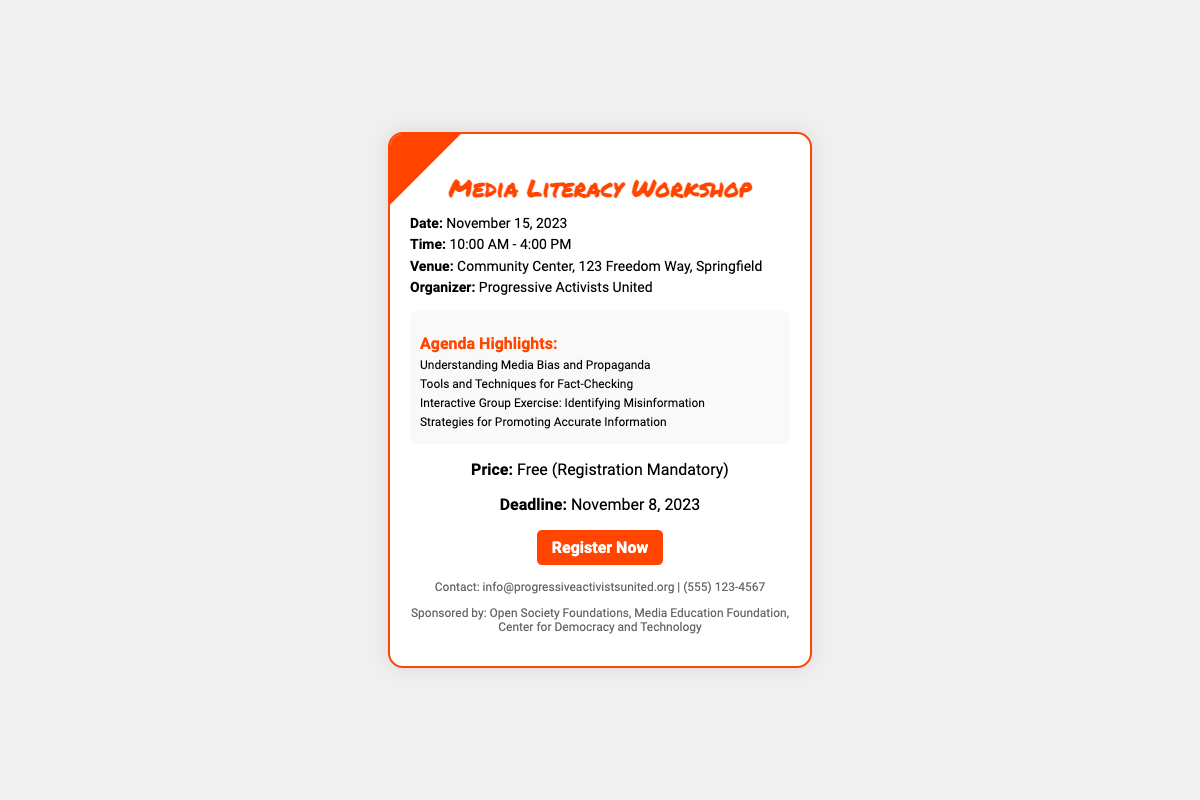What is the date of the workshop? The date of the workshop is specifically mentioned in the document as November 15, 2023.
Answer: November 15, 2023 What are the workshop hours? The document states the workshop hours are from 10:00 AM to 4:00 PM.
Answer: 10:00 AM - 4:00 PM Where is the workshop being held? The venue for the workshop is provided in the document as Community Center, 123 Freedom Way, Springfield.
Answer: Community Center, 123 Freedom Way, Springfield Who is organizing the workshop? The document lists the organizer as Progressive Activists United.
Answer: Progressive Activists United What is the price to attend the workshop? The document clearly mentions that the price to attend the workshop is free.
Answer: Free What is the registration deadline? The registration deadline is stated in the document as November 8, 2023.
Answer: November 8, 2023 What is one of the agenda highlights? The document lists several agenda highlights, one of which is Understanding Media Bias and Propaganda.
Answer: Understanding Media Bias and Propaganda Why is registration mandatory? Registration is mandatory to attend the workshop as indicated in the document as “Registration Mandatory.”
Answer: Registration Mandatory Which organizations sponsored the event? The document indicates that the event is sponsored by Open Society Foundations, Media Education Foundation, Center for Democracy and Technology.
Answer: Open Society Foundations, Media Education Foundation, Center for Democracy and Technology 